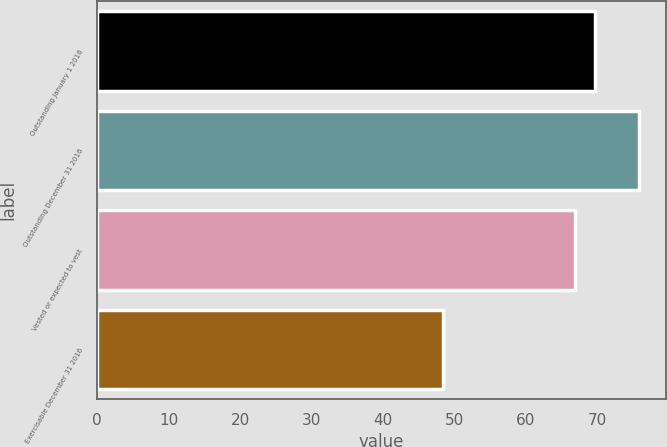Convert chart. <chart><loc_0><loc_0><loc_500><loc_500><bar_chart><fcel>Outstanding January 1 2016<fcel>Outstanding December 31 2016<fcel>Vested or expected to vest<fcel>Exercisable December 31 2016<nl><fcel>69.64<fcel>75.84<fcel>66.9<fcel>48.43<nl></chart> 